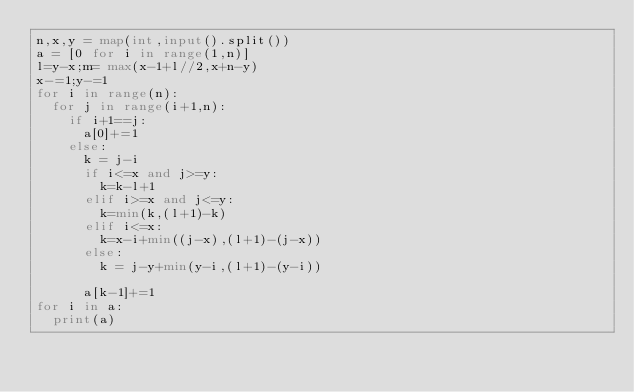<code> <loc_0><loc_0><loc_500><loc_500><_Python_>n,x,y = map(int,input().split())
a = [0 for i in range(1,n)]
l=y-x;m= max(x-1+l//2,x+n-y)
x-=1;y-=1
for i in range(n):
  for j in range(i+1,n):
    if i+1==j:
      a[0]+=1
    else:
      k = j-i
      if i<=x and j>=y:
      	k=k-l+1
      elif i>=x and j<=y:
        k=min(k,(l+1)-k)
      elif i<=x:
        k=x-i+min((j-x),(l+1)-(j-x))
      else:
        k = j-y+min(y-i,(l+1)-(y-i))  

      a[k-1]+=1
for i in a:
  print(a)</code> 